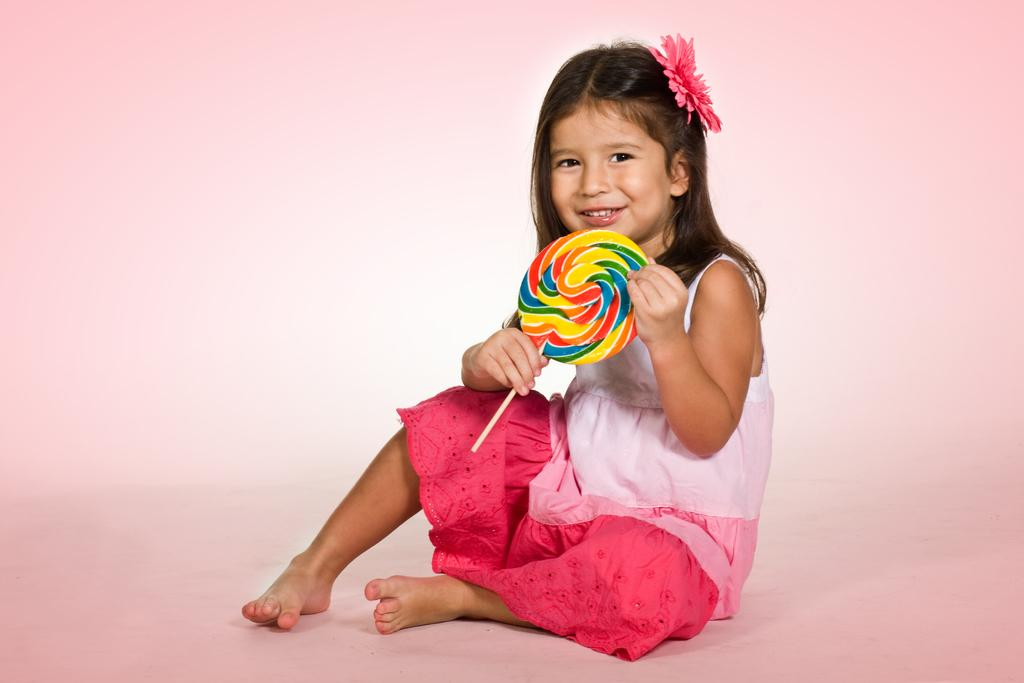Who is the main subject in the image? There is a girl in the image. Where is the girl located in the image? The girl is in the center of the image. What is the girl holding in her hand? The girl is holding a candy in her hand. What type of pie is the girl eating in the image? There is no pie present in the image; the girl is holding a candy. Is the girl in prison in the image? There is no indication of a prison or any confinement in the image; it simply shows a girl holding a candy. 